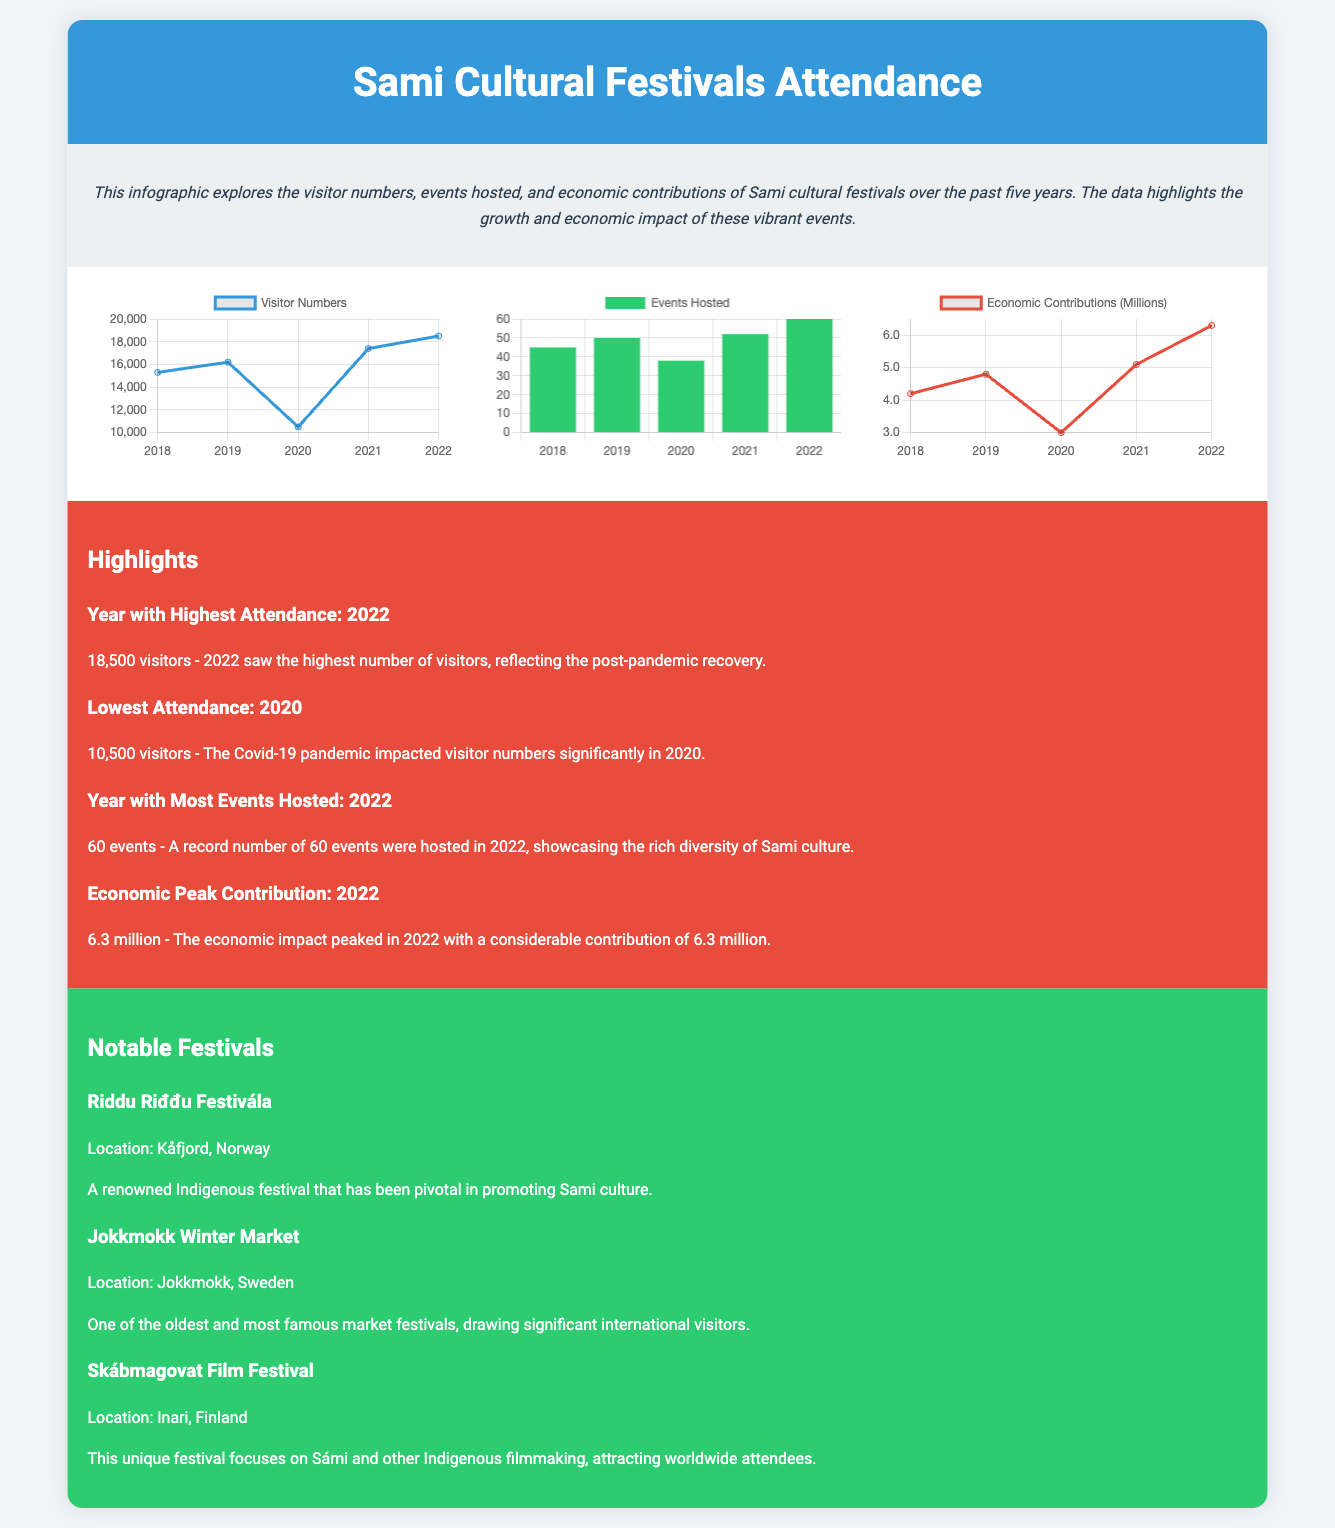What year had the highest attendance? The document states that 2022 had the highest number of visitors of 18,500.
Answer: 2022 What was the lowest attendance? According to the infographic, the lowest attendance recorded was in 2020 with 10,500 visitors.
Answer: 10,500 How many events were hosted in 2022? The document highlights that 2022 hosted a total of 60 events, which was the highest number recorded.
Answer: 60 What was the economic contribution in millions for 2022? The economic impact in 2022 peaked at 6.3 million, as stated in the document.
Answer: 6.3 million Which festival is located in Kåfjord, Norway? The document notes that the Riddu Riđđu Festivála is the festival held in Kåfjord, Norway.
Answer: Riddu Riđđu Festivála What trend can be seen in visitor numbers from 2018 to 2022? An observed trend indicates a steady increase in visitor numbers leading up to 2022, especially after the dip in 2020.
Answer: Increase How many total years of data is presented in this infographic? The infographic presents data for five years, from 2018 to 2022.
Answer: Five What is the primary purpose of the infographic? The primary purpose is to explore visitor numbers, events hosted, and economic contributions of Sami cultural festivals.
Answer: Explore contributions What specific type of chart is used for showing economic contributions? The document specifies that a line chart is used for illustrating economic contributions.
Answer: Line chart 